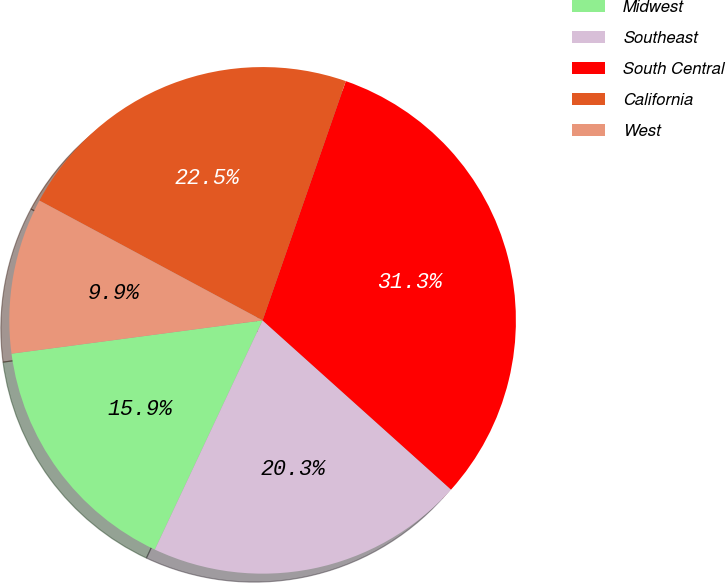Convert chart to OTSL. <chart><loc_0><loc_0><loc_500><loc_500><pie_chart><fcel>Midwest<fcel>Southeast<fcel>South Central<fcel>California<fcel>West<nl><fcel>15.91%<fcel>20.35%<fcel>31.32%<fcel>22.49%<fcel>9.94%<nl></chart> 